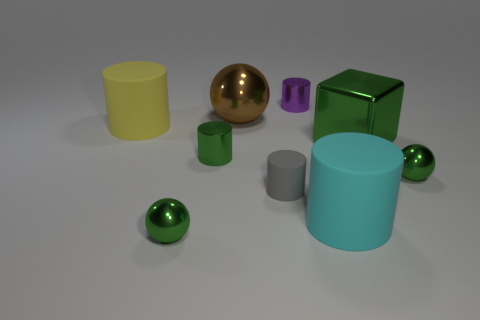There is a ball that is right of the big metal cube; how many small shiny spheres are right of it?
Make the answer very short. 0. Is the shape of the large cyan object the same as the brown shiny object?
Offer a terse response. No. Is there anything else of the same color as the tiny matte cylinder?
Give a very brief answer. No. There is a small purple thing; is it the same shape as the large rubber thing in front of the gray thing?
Your answer should be compact. Yes. What is the color of the matte thing behind the tiny green metallic thing that is behind the tiny metal object that is on the right side of the big cyan cylinder?
Provide a succinct answer. Yellow. Is there any other thing that is made of the same material as the yellow object?
Provide a succinct answer. Yes. Do the big metal object in front of the big sphere and the gray matte thing have the same shape?
Keep it short and to the point. No. What material is the brown object?
Keep it short and to the point. Metal. There is a large object that is in front of the ball that is to the right of the cylinder behind the large yellow thing; what is its shape?
Make the answer very short. Cylinder. How many other objects are there of the same shape as the purple metallic thing?
Provide a succinct answer. 4. 